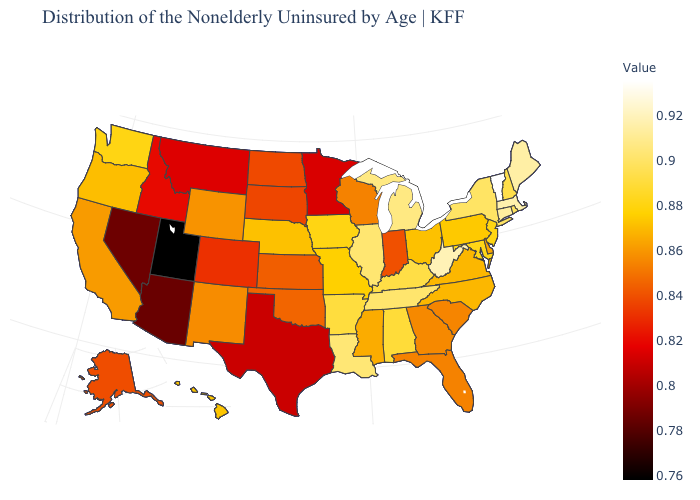Among the states that border Oregon , which have the highest value?
Write a very short answer. Washington. Does Michigan have the lowest value in the USA?
Give a very brief answer. No. Among the states that border Idaho , which have the highest value?
Be succinct. Washington. 